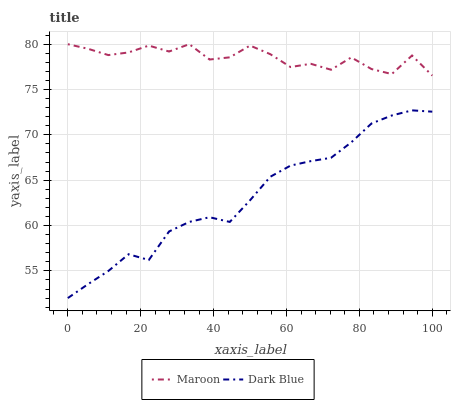Does Dark Blue have the minimum area under the curve?
Answer yes or no. Yes. Does Maroon have the maximum area under the curve?
Answer yes or no. Yes. Does Maroon have the minimum area under the curve?
Answer yes or no. No. Is Dark Blue the smoothest?
Answer yes or no. Yes. Is Maroon the roughest?
Answer yes or no. Yes. Is Maroon the smoothest?
Answer yes or no. No. Does Dark Blue have the lowest value?
Answer yes or no. Yes. Does Maroon have the lowest value?
Answer yes or no. No. Does Maroon have the highest value?
Answer yes or no. Yes. Is Dark Blue less than Maroon?
Answer yes or no. Yes. Is Maroon greater than Dark Blue?
Answer yes or no. Yes. Does Dark Blue intersect Maroon?
Answer yes or no. No. 